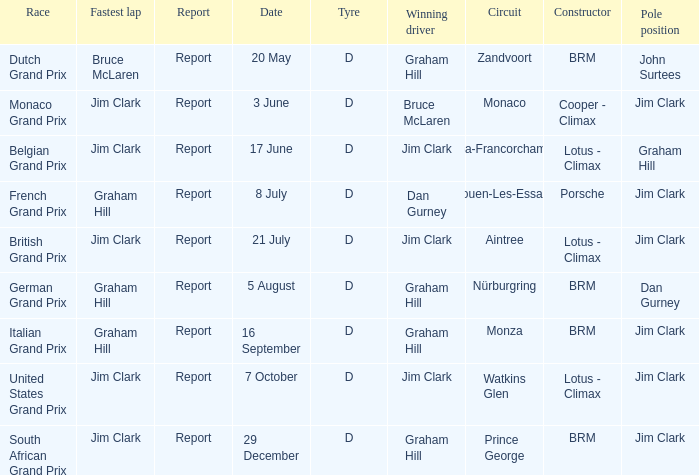What is the constructor at the United States Grand Prix? Lotus - Climax. 